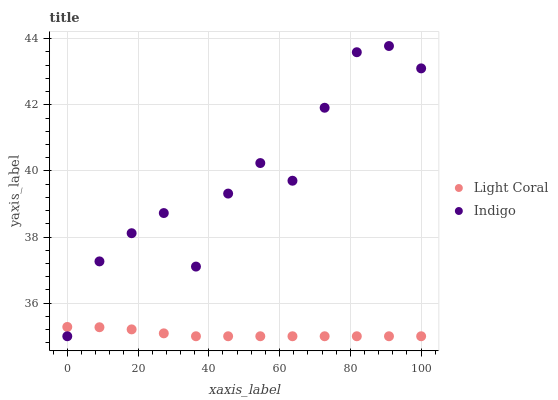Does Light Coral have the minimum area under the curve?
Answer yes or no. Yes. Does Indigo have the maximum area under the curve?
Answer yes or no. Yes. Does Indigo have the minimum area under the curve?
Answer yes or no. No. Is Light Coral the smoothest?
Answer yes or no. Yes. Is Indigo the roughest?
Answer yes or no. Yes. Is Indigo the smoothest?
Answer yes or no. No. Does Light Coral have the lowest value?
Answer yes or no. Yes. Does Indigo have the highest value?
Answer yes or no. Yes. Does Indigo intersect Light Coral?
Answer yes or no. Yes. Is Indigo less than Light Coral?
Answer yes or no. No. Is Indigo greater than Light Coral?
Answer yes or no. No. 